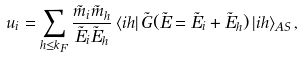Convert formula to latex. <formula><loc_0><loc_0><loc_500><loc_500>u _ { i } = \sum _ { h \leq k _ { F } } \frac { \tilde { m } _ { i } \tilde { m } _ { h } } { \tilde { E } _ { i } \tilde { E } _ { h } } \left \langle i h \right | \tilde { G } ( \tilde { E } = \tilde { E } _ { i } + \tilde { E } _ { h } ) \left | i h \right \rangle _ { A S } ,</formula> 